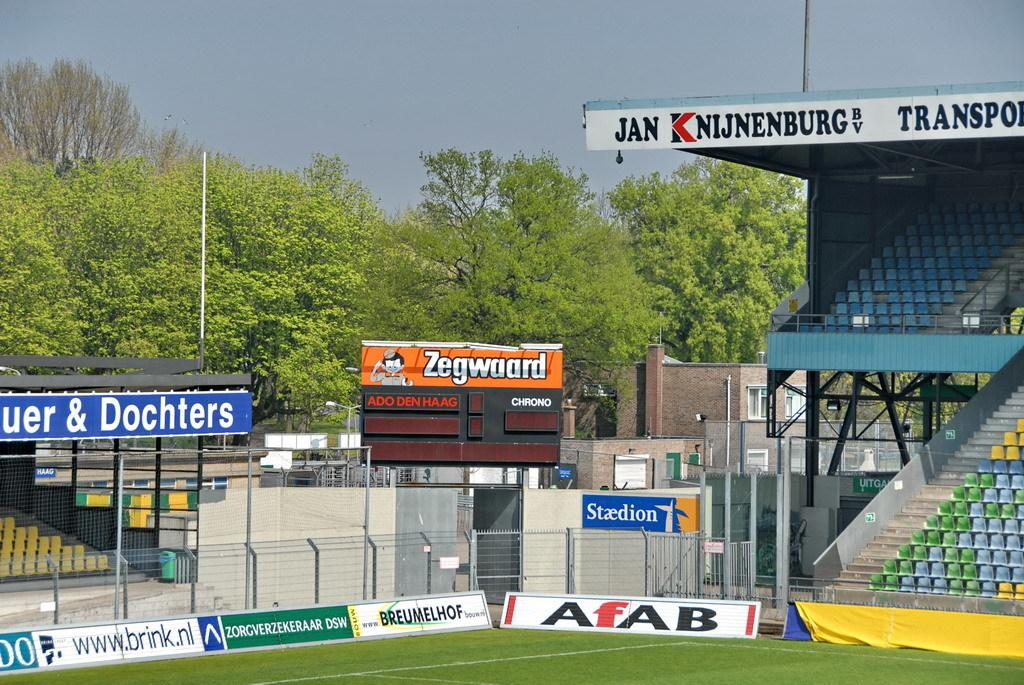<image>
Create a compact narrative representing the image presented. A stadium scene with an advertisement for Zegwaard. 